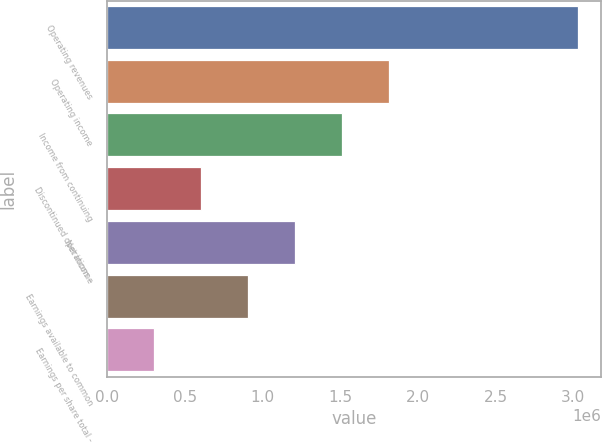Convert chart to OTSL. <chart><loc_0><loc_0><loc_500><loc_500><bar_chart><fcel>Operating revenues<fcel>Operating income<fcel>Income from continuing<fcel>Discontinued operations -<fcel>Net income<fcel>Earnings available to common<fcel>Earnings per share total -<nl><fcel>3.02839e+06<fcel>1.81703e+06<fcel>1.51419e+06<fcel>605678<fcel>1.21136e+06<fcel>908517<fcel>302839<nl></chart> 